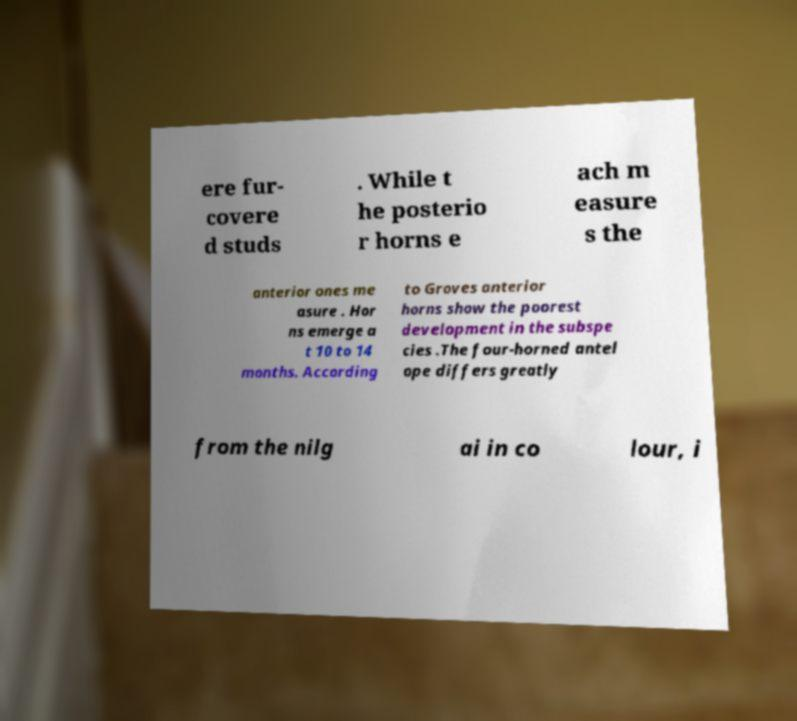Can you accurately transcribe the text from the provided image for me? ere fur- covere d studs . While t he posterio r horns e ach m easure s the anterior ones me asure . Hor ns emerge a t 10 to 14 months. According to Groves anterior horns show the poorest development in the subspe cies .The four-horned antel ope differs greatly from the nilg ai in co lour, i 